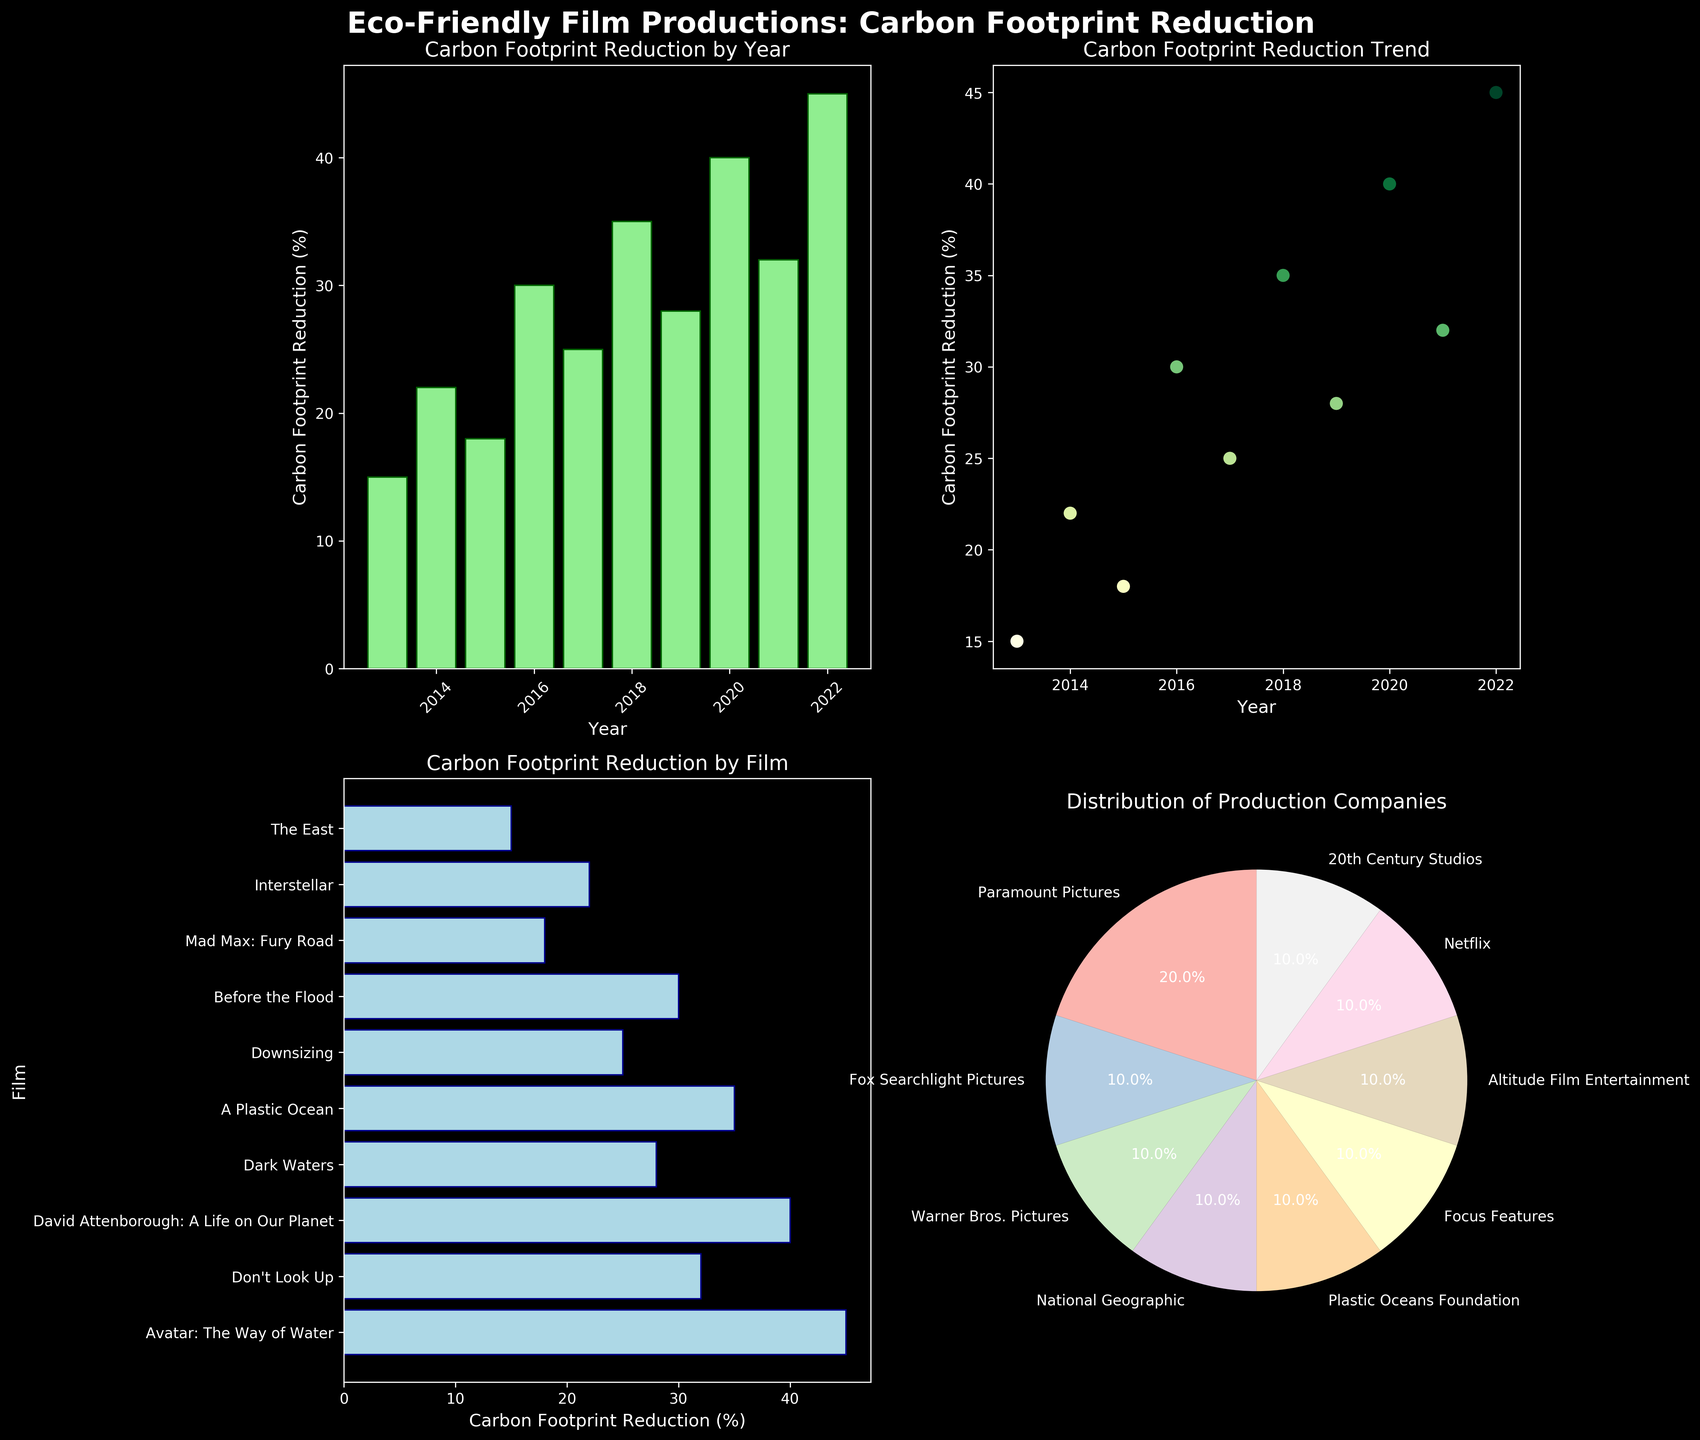what is the title of the plot in the top-left corner? The title of the top-left subplot is written at the top of that specific plot. It reads "Carbon Footprint Reduction by Year."
Answer: Carbon Footprint Reduction by Year Which year had the highest carbon footprint reduction? Look at the x-axis of the bar chart in the top-left subplot and identify the highest bar. The year associated with this bar is 2022, and it had the highest carbon footprint reduction.
Answer: 2022 Which film achieved a 40% carbon footprint reduction? Refer to the horizontal bar chart in the bottom-left subplot. The bars are labeled with film names, and "David Attenborough: A Life on Our Planet" corresponds to the 40% reduction mark.
Answer: David Attenborough: A Life on Our Planet Which production company has the largest share in the pie chart? In the pie chart in the bottom-right subplot, the portions of each segment represent different production companies. Identify the largest segment. The largest share is taken by Paramount Pictures.
Answer: Paramount Pictures How does the carbon footprint reduction trend change over the years? Look at the scatter plot in the top-right subplot; the dots show a trend over multiple years. There is generally an increasing trend in carbon footprint reduction as the years progress.
Answer: Increasing trend Which film released in 2019 and what was its carbon footprint reduction percentage? Check the horizontal bar chart for the film names and their respective percentages. "Dark Waters" was released in 2019 and had a 28% carbon footprint reduction.
Answer: Dark Waters, 28% Compare the carbon footprint reduction of the films in 2014 and 2017. Which one had a higher reduction? Examine the bar chart and scatter plot for the years 2014 and 2017. In 2014, "Interstellar" had a reduction of 22%, while in 2017, "Downsizing" had a reduction of 25%. "Downsizing" in 2017 had a higher reduction.
Answer: Downsizing in 2017 What is the average carbon footprint reduction for the films listed? Sum the percentage values and divide by the total number of films. (15 + 22 + 18 + 30 + 25 + 35 + 28 + 40 + 32 + 45) / 10 = 29.0%
Answer: 29.0% Which production company contributed to the film with the highest carbon footprint reduction? To find the top carbon footprint reduction, refer to the bar chart or scatter plot, showing "Avatar: The Way of Water" in 2022 with a 45% reduction. The production company is 20th Century Studios.
Answer: 20th Century Studios Did the years 2020 and 2021 both have films with at least 30% carbon footprint reduction? Look at the bar chart data for 2020 and 2021. Both years show reductions of 40% and 32%, respectively. Both values are above 30%.
Answer: Yes 